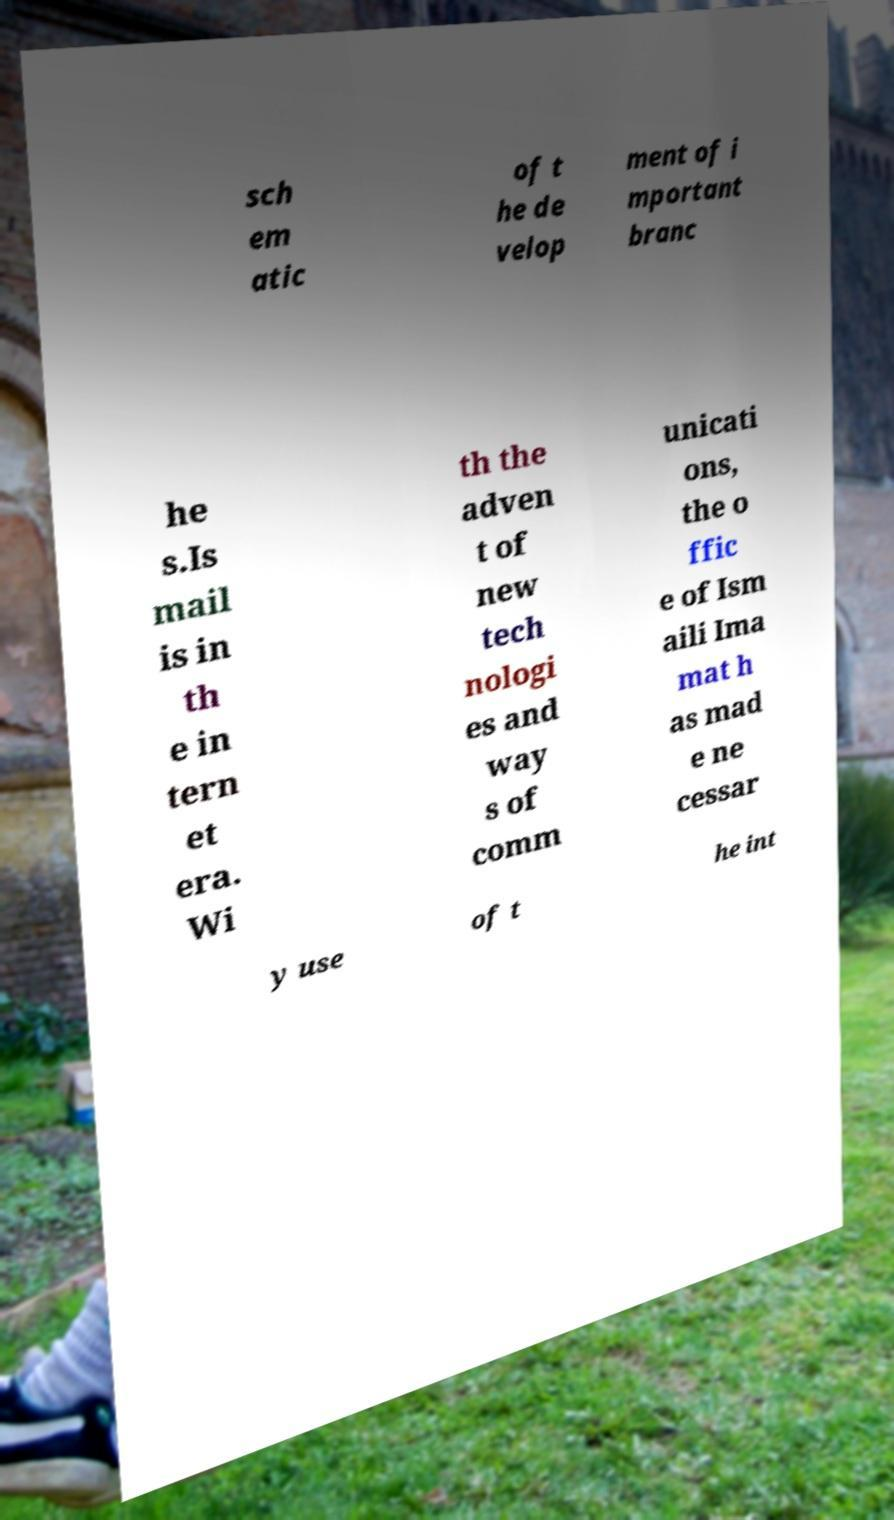Could you extract and type out the text from this image? sch em atic of t he de velop ment of i mportant branc he s.Is mail is in th e in tern et era. Wi th the adven t of new tech nologi es and way s of comm unicati ons, the o ffic e of Ism aili Ima mat h as mad e ne cessar y use of t he int 